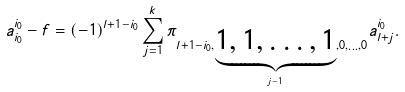Convert formula to latex. <formula><loc_0><loc_0><loc_500><loc_500>a _ { i _ { 0 } } ^ { i _ { 0 } } - f = ( - 1 ) ^ { l + 1 - i _ { 0 } } \sum _ { j = 1 } ^ { k } \pi _ { l + 1 - i _ { 0 } , { \underbrace { 1 , 1 , \dots , 1 } _ { j - 1 } } , 0 , \dots , 0 } a _ { l + j } ^ { i _ { 0 } } .</formula> 